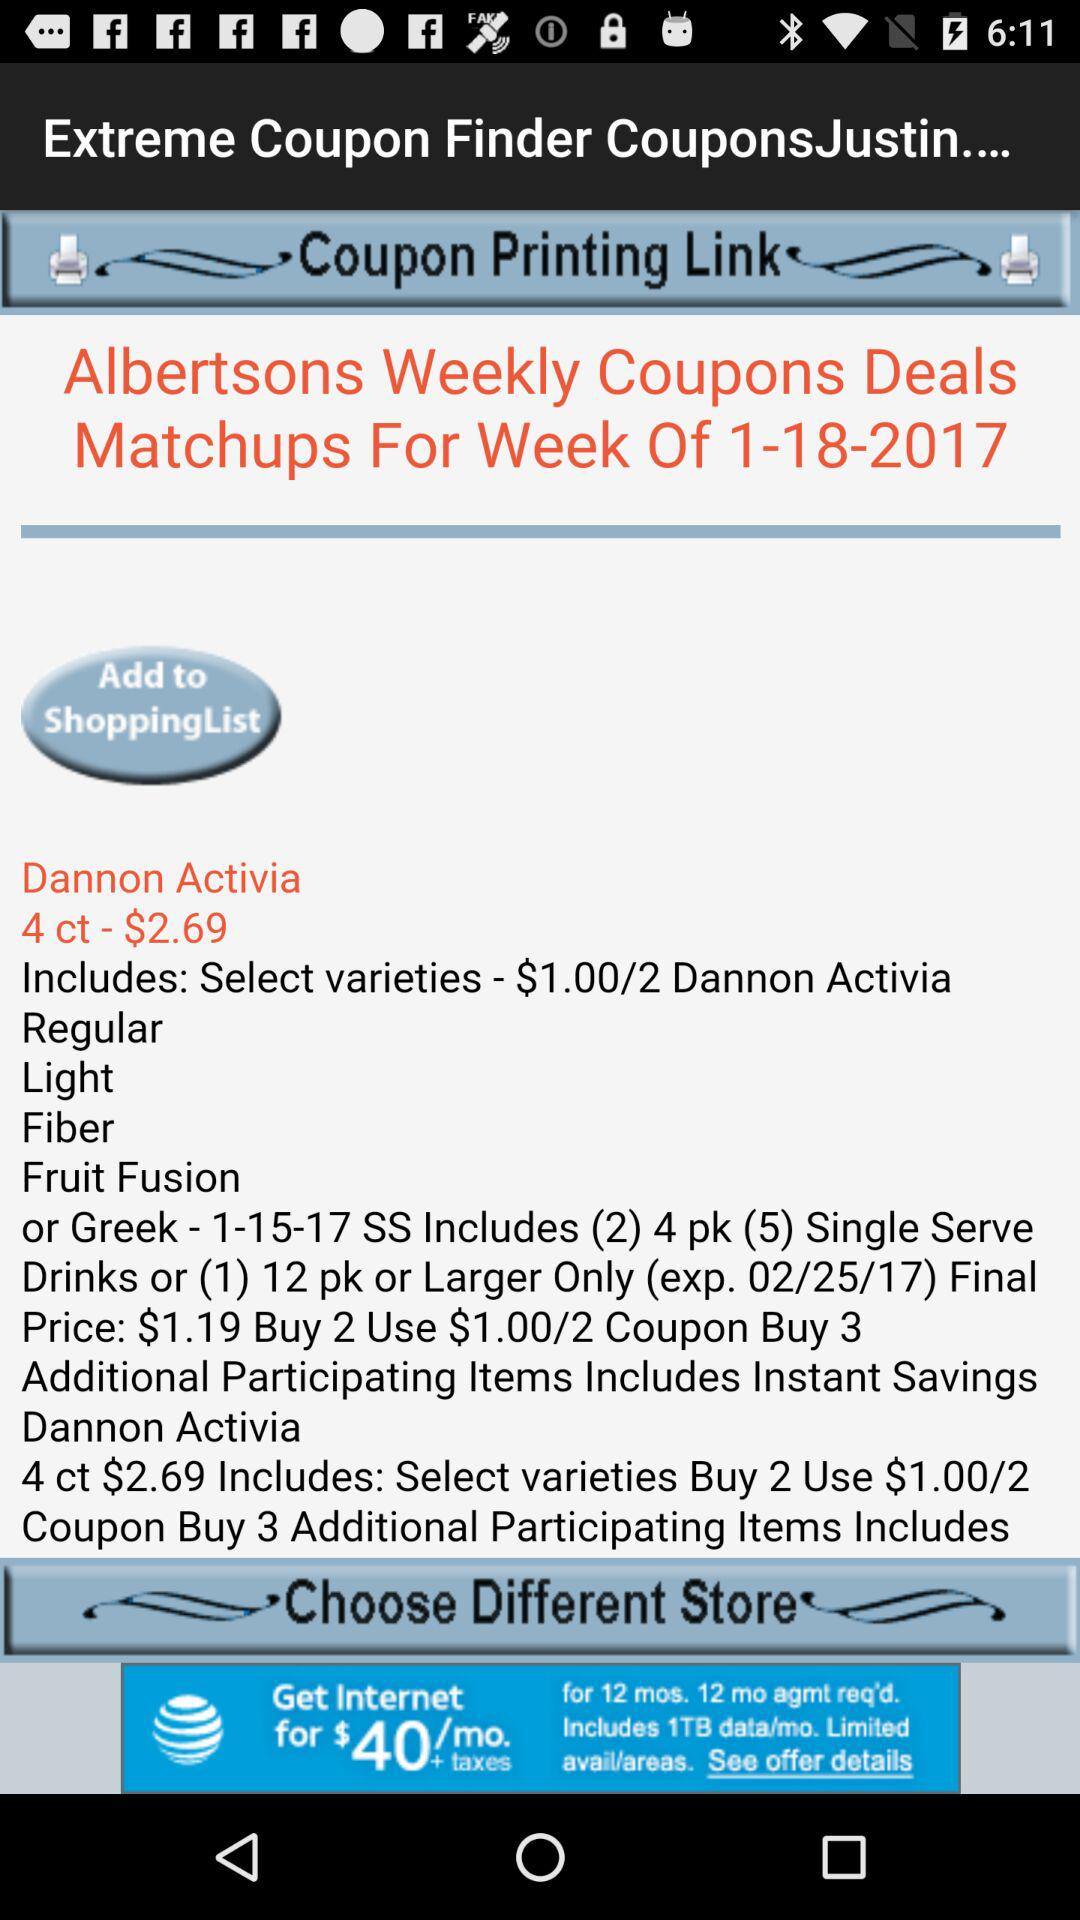What is the cost of Dannon Activia 4 ct? The cost is $2.69. 